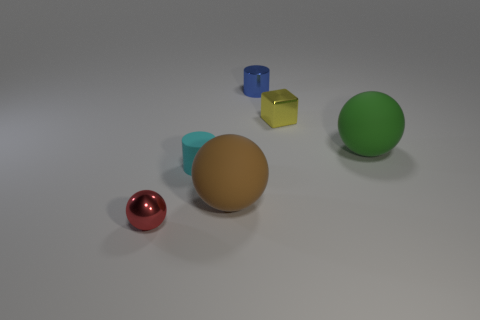Is the color of the tiny shiny cube the same as the rubber ball left of the blue metallic cylinder?
Your response must be concise. No. There is a green ball that is made of the same material as the brown ball; what is its size?
Your response must be concise. Large. Are there more big green rubber spheres that are in front of the small red object than red spheres?
Ensure brevity in your answer.  No. There is a big object in front of the big matte object that is behind the cylinder left of the small blue object; what is it made of?
Your response must be concise. Rubber. Does the small sphere have the same material as the thing that is behind the small yellow metal object?
Offer a terse response. Yes. There is a cyan object that is the same shape as the tiny blue metallic thing; what is its material?
Offer a very short reply. Rubber. Are there any other things that have the same material as the large green thing?
Give a very brief answer. Yes. Are there more small cylinders behind the tiny red shiny ball than metallic things left of the small cube?
Offer a very short reply. No. The red thing that is made of the same material as the blue object is what shape?
Provide a succinct answer. Sphere. How many other objects are there of the same shape as the small yellow shiny thing?
Keep it short and to the point. 0. 